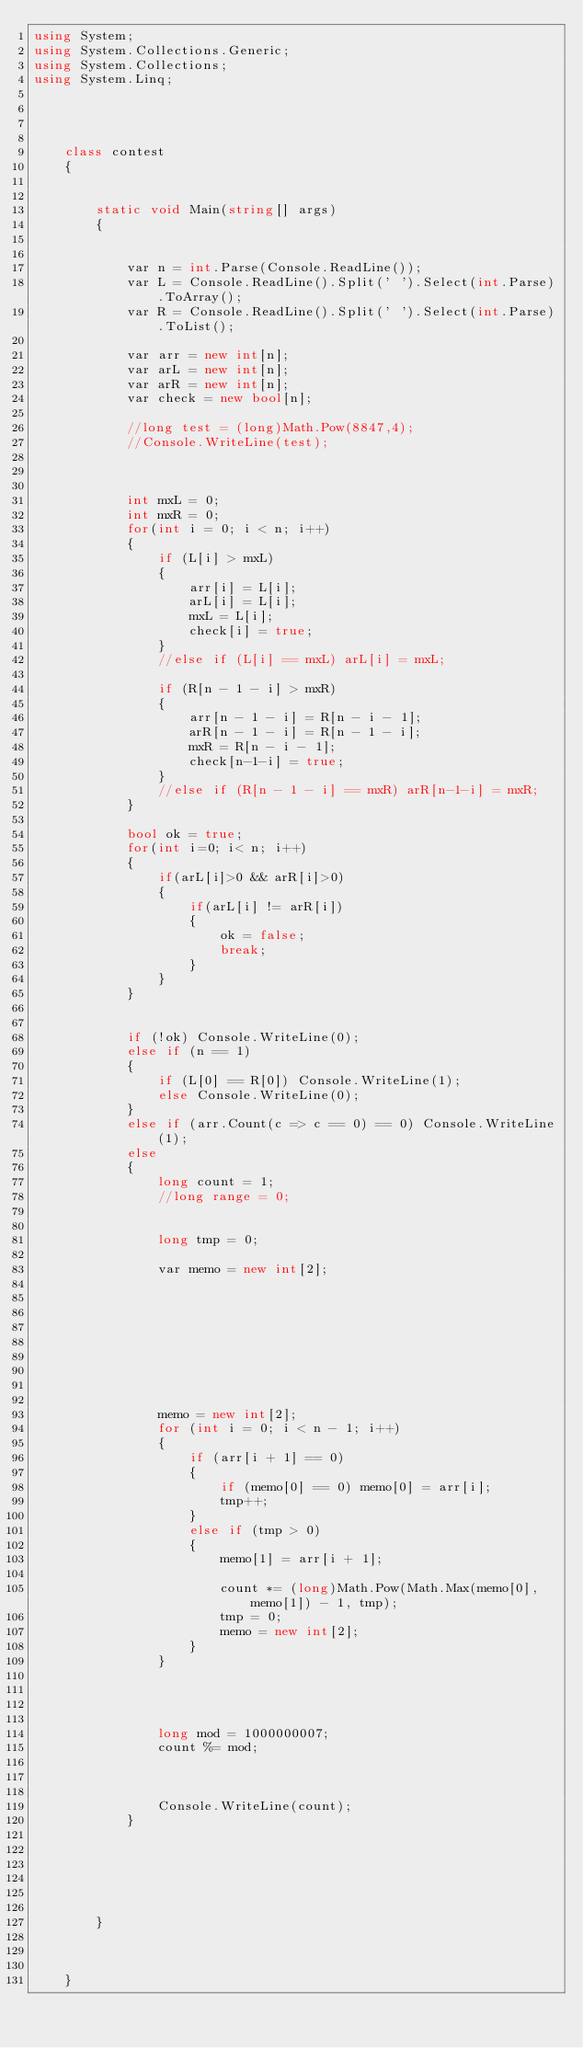<code> <loc_0><loc_0><loc_500><loc_500><_C#_>using System;
using System.Collections.Generic;
using System.Collections;
using System.Linq;




	class contest
	{
				
		
		static void Main(string[] args)
		{

		  
            var n = int.Parse(Console.ReadLine());
            var L = Console.ReadLine().Split(' ').Select(int.Parse).ToArray();            
            var R = Console.ReadLine().Split(' ').Select(int.Parse).ToList();

            var arr = new int[n];
            var arL = new int[n];
            var arR = new int[n];
            var check = new bool[n];

            //long test = (long)Math.Pow(8847,4);
            //Console.WriteLine(test);
            


            int mxL = 0;
            int mxR = 0;
            for(int i = 0; i < n; i++)
            {
                if (L[i] > mxL)
                {
                    arr[i] = L[i];
                    arL[i] = L[i];
                    mxL = L[i];
                    check[i] = true;
                }
                //else if (L[i] == mxL) arL[i] = mxL;

                if (R[n - 1 - i] > mxR)
                {
                    arr[n - 1 - i] = R[n - i - 1];
                    arR[n - 1 - i] = R[n - 1 - i];
                    mxR = R[n - i - 1];
                    check[n-1-i] = true;
                }
                //else if (R[n - 1 - i] == mxR) arR[n-1-i] = mxR;
            }

            bool ok = true;
            for(int i=0; i< n; i++)
            {
                if(arL[i]>0 && arR[i]>0)
                {
                    if(arL[i] != arR[i])
                    {
                        ok = false;
                        break;
                    }
                }
            }


            if (!ok) Console.WriteLine(0);
            else if (n == 1)
            {
                if (L[0] == R[0]) Console.WriteLine(1);
                else Console.WriteLine(0);
            }
            else if (arr.Count(c => c == 0) == 0) Console.WriteLine(1);
            else
            {
                long count = 1;
                //long range = 0;


                long tmp = 0;

                var memo = new int[2];









                memo = new int[2];
                for (int i = 0; i < n - 1; i++)
                {
                    if (arr[i + 1] == 0)
                    {
                        if (memo[0] == 0) memo[0] = arr[i];
                        tmp++;
                    }
                    else if (tmp > 0)
                    {
                        memo[1] = arr[i + 1];
                        
                        count *= (long)Math.Pow(Math.Max(memo[0], memo[1]) - 1, tmp);
                        tmp = 0;
                        memo = new int[2];
                    }
                }




                long mod = 1000000007;
                count %= mod;



                Console.WriteLine(count);
            }
 
           



		
        }
		
		
			
	}
</code> 